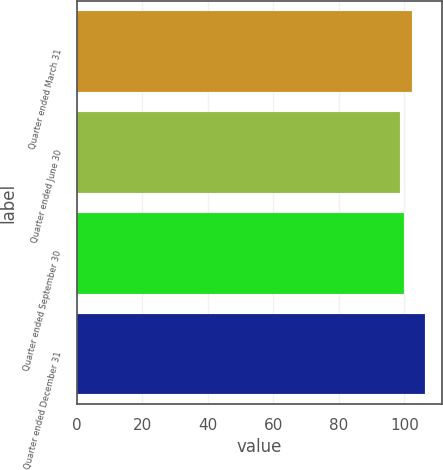<chart> <loc_0><loc_0><loc_500><loc_500><bar_chart><fcel>Quarter ended March 31<fcel>Quarter ended June 30<fcel>Quarter ended September 30<fcel>Quarter ended December 31<nl><fcel>102.31<fcel>98.64<fcel>99.9<fcel>106.31<nl></chart> 